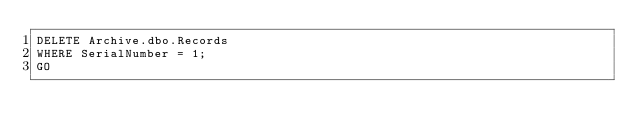<code> <loc_0><loc_0><loc_500><loc_500><_SQL_>DELETE Archive.dbo.Records
WHERE SerialNumber = 1;
GO</code> 